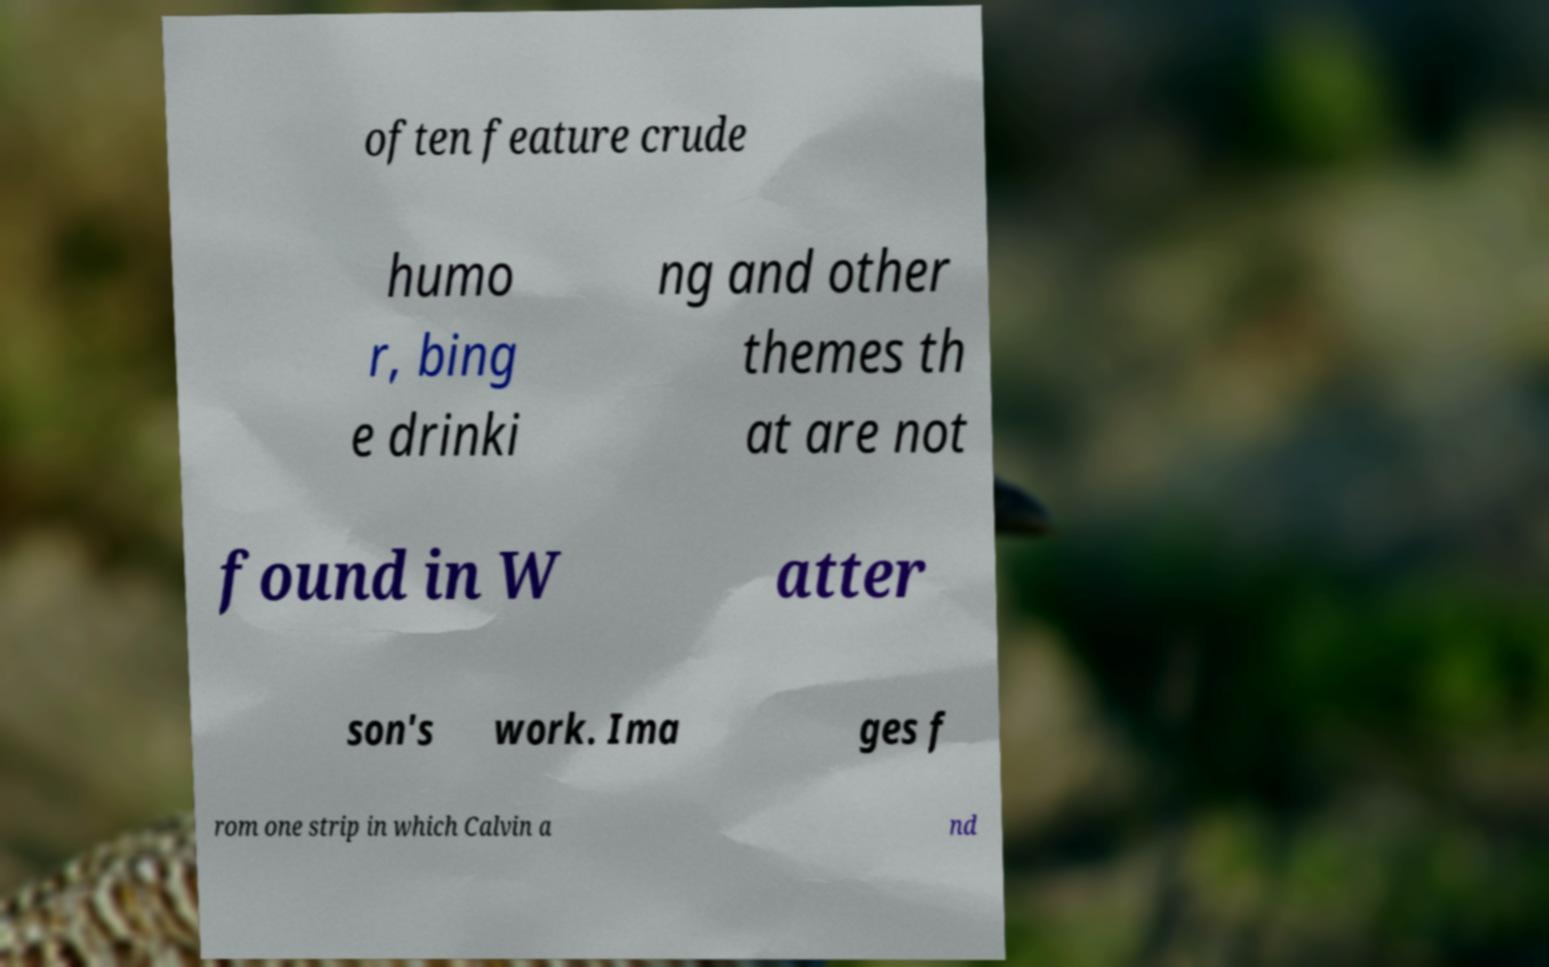For documentation purposes, I need the text within this image transcribed. Could you provide that? often feature crude humo r, bing e drinki ng and other themes th at are not found in W atter son's work. Ima ges f rom one strip in which Calvin a nd 